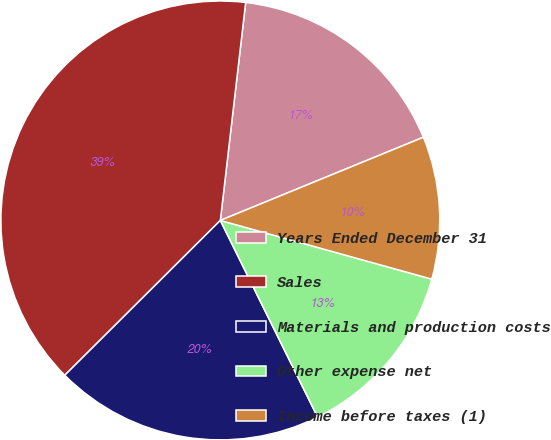<chart> <loc_0><loc_0><loc_500><loc_500><pie_chart><fcel>Years Ended December 31<fcel>Sales<fcel>Materials and production costs<fcel>Other expense net<fcel>Income before taxes (1)<nl><fcel>16.97%<fcel>39.31%<fcel>19.85%<fcel>13.38%<fcel>10.5%<nl></chart> 